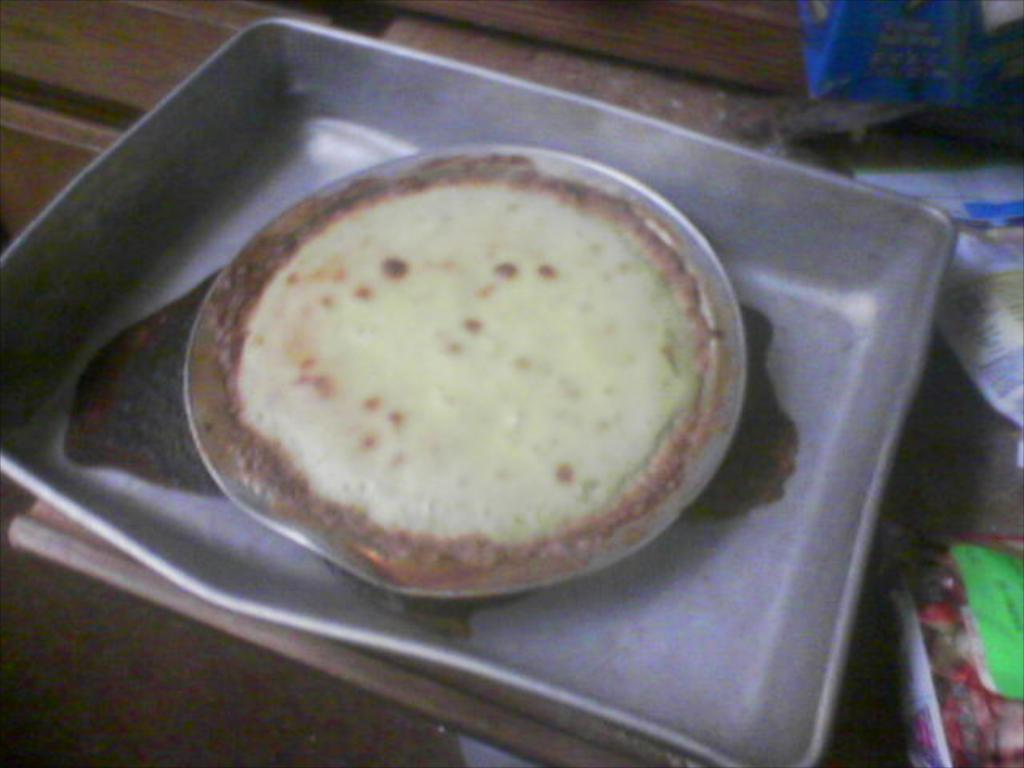What piece of furniture is present in the image? There is a table in the image. What is placed on the table? There is a tray and a cake bowl on the table. What else can be seen on the table? There are packets on the table. Can you see a duck swimming in the cake bowl in the image? There is no duck present in the image, and the cake bowl does not contain any water for a duck to swim in. 